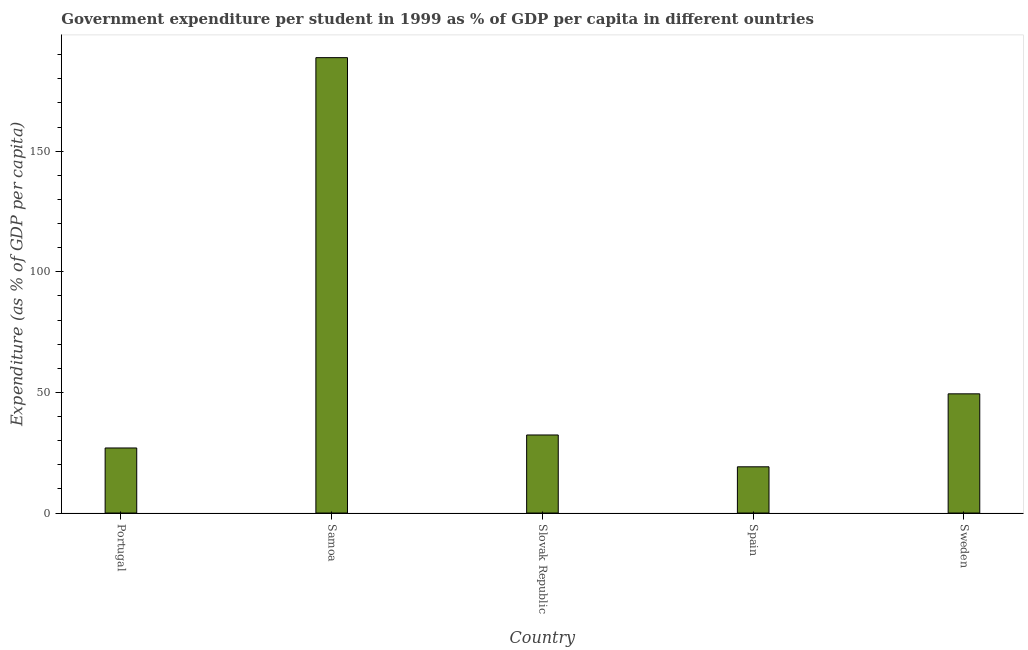Does the graph contain grids?
Your answer should be very brief. No. What is the title of the graph?
Your answer should be compact. Government expenditure per student in 1999 as % of GDP per capita in different ountries. What is the label or title of the Y-axis?
Your response must be concise. Expenditure (as % of GDP per capita). What is the government expenditure per student in Slovak Republic?
Your answer should be compact. 32.36. Across all countries, what is the maximum government expenditure per student?
Offer a terse response. 188.78. Across all countries, what is the minimum government expenditure per student?
Give a very brief answer. 19.16. In which country was the government expenditure per student maximum?
Your answer should be compact. Samoa. In which country was the government expenditure per student minimum?
Your answer should be very brief. Spain. What is the sum of the government expenditure per student?
Your response must be concise. 316.68. What is the difference between the government expenditure per student in Portugal and Slovak Republic?
Ensure brevity in your answer.  -5.39. What is the average government expenditure per student per country?
Provide a short and direct response. 63.34. What is the median government expenditure per student?
Provide a short and direct response. 32.36. What is the ratio of the government expenditure per student in Portugal to that in Slovak Republic?
Offer a terse response. 0.83. Is the government expenditure per student in Spain less than that in Sweden?
Offer a terse response. Yes. Is the difference between the government expenditure per student in Portugal and Samoa greater than the difference between any two countries?
Offer a very short reply. No. What is the difference between the highest and the second highest government expenditure per student?
Provide a succinct answer. 139.36. Is the sum of the government expenditure per student in Slovak Republic and Sweden greater than the maximum government expenditure per student across all countries?
Provide a short and direct response. No. What is the difference between the highest and the lowest government expenditure per student?
Make the answer very short. 169.62. How many countries are there in the graph?
Ensure brevity in your answer.  5. What is the difference between two consecutive major ticks on the Y-axis?
Provide a short and direct response. 50. What is the Expenditure (as % of GDP per capita) in Portugal?
Offer a terse response. 26.97. What is the Expenditure (as % of GDP per capita) in Samoa?
Offer a very short reply. 188.78. What is the Expenditure (as % of GDP per capita) in Slovak Republic?
Make the answer very short. 32.36. What is the Expenditure (as % of GDP per capita) of Spain?
Provide a succinct answer. 19.16. What is the Expenditure (as % of GDP per capita) of Sweden?
Your answer should be compact. 49.41. What is the difference between the Expenditure (as % of GDP per capita) in Portugal and Samoa?
Provide a short and direct response. -161.81. What is the difference between the Expenditure (as % of GDP per capita) in Portugal and Slovak Republic?
Provide a short and direct response. -5.39. What is the difference between the Expenditure (as % of GDP per capita) in Portugal and Spain?
Provide a short and direct response. 7.81. What is the difference between the Expenditure (as % of GDP per capita) in Portugal and Sweden?
Offer a terse response. -22.45. What is the difference between the Expenditure (as % of GDP per capita) in Samoa and Slovak Republic?
Provide a succinct answer. 156.42. What is the difference between the Expenditure (as % of GDP per capita) in Samoa and Spain?
Give a very brief answer. 169.62. What is the difference between the Expenditure (as % of GDP per capita) in Samoa and Sweden?
Provide a succinct answer. 139.36. What is the difference between the Expenditure (as % of GDP per capita) in Slovak Republic and Spain?
Make the answer very short. 13.2. What is the difference between the Expenditure (as % of GDP per capita) in Slovak Republic and Sweden?
Offer a very short reply. -17.06. What is the difference between the Expenditure (as % of GDP per capita) in Spain and Sweden?
Keep it short and to the point. -30.25. What is the ratio of the Expenditure (as % of GDP per capita) in Portugal to that in Samoa?
Your answer should be very brief. 0.14. What is the ratio of the Expenditure (as % of GDP per capita) in Portugal to that in Slovak Republic?
Offer a terse response. 0.83. What is the ratio of the Expenditure (as % of GDP per capita) in Portugal to that in Spain?
Keep it short and to the point. 1.41. What is the ratio of the Expenditure (as % of GDP per capita) in Portugal to that in Sweden?
Offer a terse response. 0.55. What is the ratio of the Expenditure (as % of GDP per capita) in Samoa to that in Slovak Republic?
Make the answer very short. 5.83. What is the ratio of the Expenditure (as % of GDP per capita) in Samoa to that in Spain?
Offer a very short reply. 9.85. What is the ratio of the Expenditure (as % of GDP per capita) in Samoa to that in Sweden?
Ensure brevity in your answer.  3.82. What is the ratio of the Expenditure (as % of GDP per capita) in Slovak Republic to that in Spain?
Offer a terse response. 1.69. What is the ratio of the Expenditure (as % of GDP per capita) in Slovak Republic to that in Sweden?
Offer a very short reply. 0.66. What is the ratio of the Expenditure (as % of GDP per capita) in Spain to that in Sweden?
Ensure brevity in your answer.  0.39. 